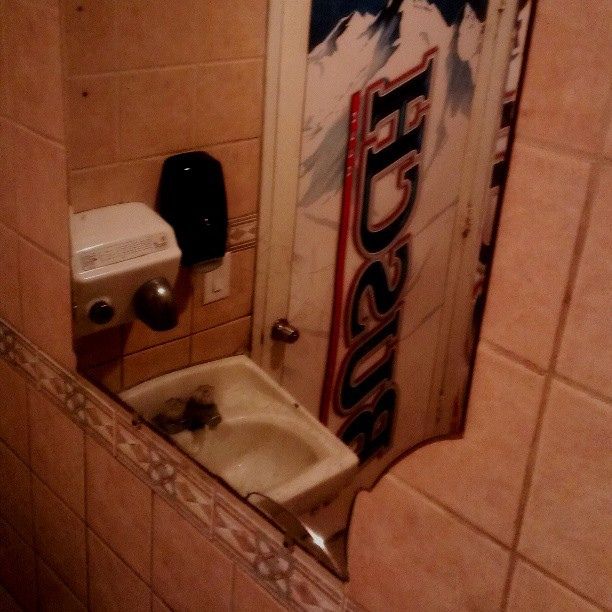Read all the text in this image. BUSCH 